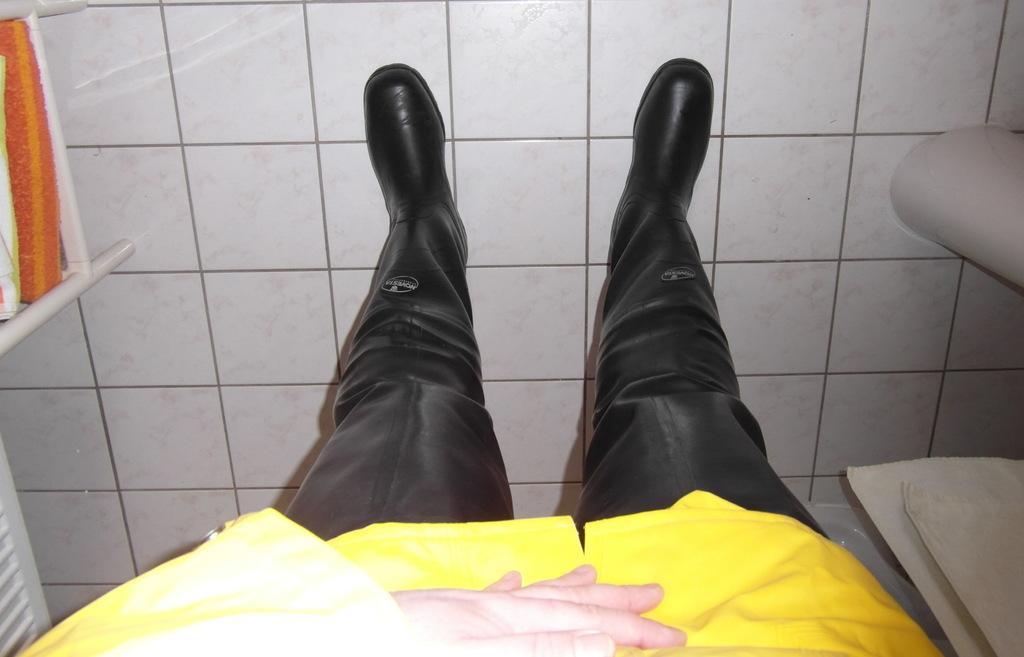Could you give a brief overview of what you see in this image? This image is in reverse direction. In this image, I can see a man wearing a yellow color jacket, boots and standing on the floor. On the left side there is a table on which I can see few clothes. On the right side there are few objects. 